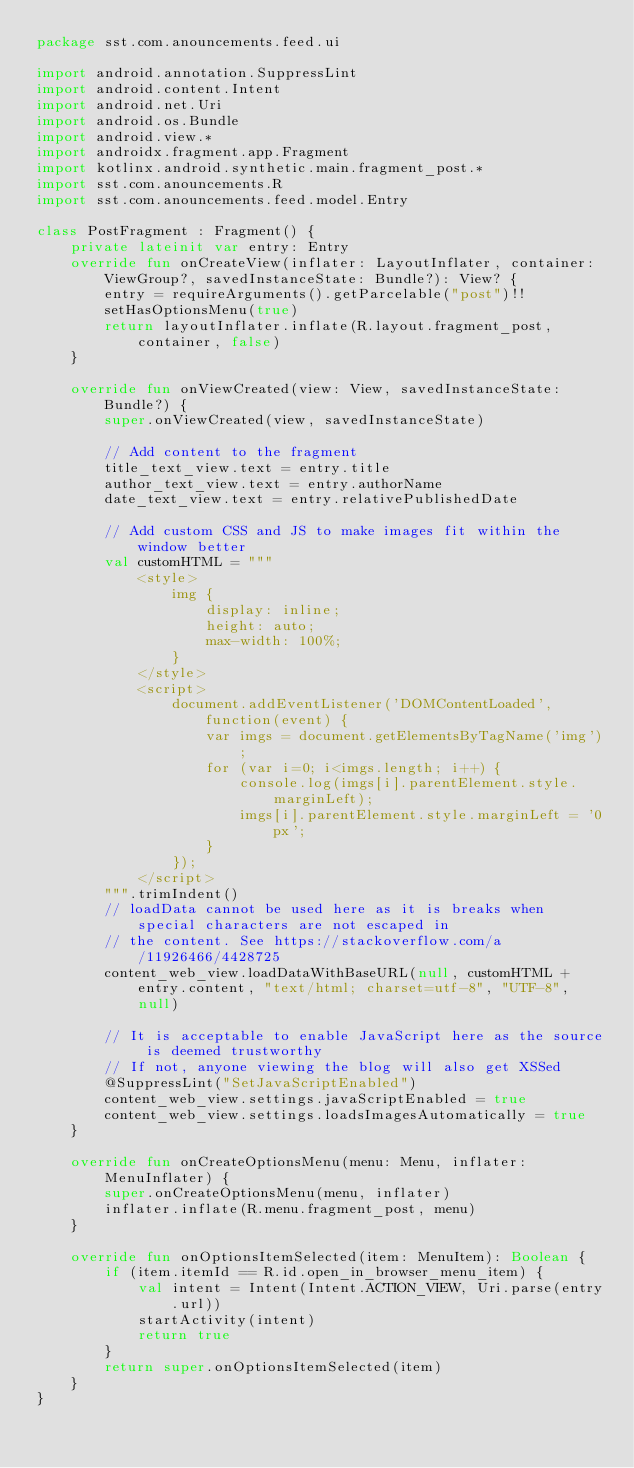<code> <loc_0><loc_0><loc_500><loc_500><_Kotlin_>package sst.com.anouncements.feed.ui

import android.annotation.SuppressLint
import android.content.Intent
import android.net.Uri
import android.os.Bundle
import android.view.*
import androidx.fragment.app.Fragment
import kotlinx.android.synthetic.main.fragment_post.*
import sst.com.anouncements.R
import sst.com.anouncements.feed.model.Entry

class PostFragment : Fragment() {
    private lateinit var entry: Entry
    override fun onCreateView(inflater: LayoutInflater, container: ViewGroup?, savedInstanceState: Bundle?): View? {
        entry = requireArguments().getParcelable("post")!!
        setHasOptionsMenu(true)
        return layoutInflater.inflate(R.layout.fragment_post, container, false)
    }

    override fun onViewCreated(view: View, savedInstanceState: Bundle?) {
        super.onViewCreated(view, savedInstanceState)

        // Add content to the fragment
        title_text_view.text = entry.title
        author_text_view.text = entry.authorName
        date_text_view.text = entry.relativePublishedDate

        // Add custom CSS and JS to make images fit within the window better
        val customHTML = """
            <style>
                img {
                    display: inline;
                    height: auto;
                    max-width: 100%;
                }
            </style>
            <script>
                document.addEventListener('DOMContentLoaded', function(event) {
                    var imgs = document.getElementsByTagName('img');
                    for (var i=0; i<imgs.length; i++) {
                        console.log(imgs[i].parentElement.style.marginLeft);
                        imgs[i].parentElement.style.marginLeft = '0px';
                    }
                });
            </script>
        """.trimIndent()
        // loadData cannot be used here as it is breaks when special characters are not escaped in
        // the content. See https://stackoverflow.com/a/11926466/4428725
        content_web_view.loadDataWithBaseURL(null, customHTML + entry.content, "text/html; charset=utf-8", "UTF-8", null)

        // It is acceptable to enable JavaScript here as the source is deemed trustworthy
        // If not, anyone viewing the blog will also get XSSed
        @SuppressLint("SetJavaScriptEnabled")
        content_web_view.settings.javaScriptEnabled = true
        content_web_view.settings.loadsImagesAutomatically = true
    }

    override fun onCreateOptionsMenu(menu: Menu, inflater: MenuInflater) {
        super.onCreateOptionsMenu(menu, inflater)
        inflater.inflate(R.menu.fragment_post, menu)
    }

    override fun onOptionsItemSelected(item: MenuItem): Boolean {
        if (item.itemId == R.id.open_in_browser_menu_item) {
            val intent = Intent(Intent.ACTION_VIEW, Uri.parse(entry.url))
            startActivity(intent)
            return true
        }
        return super.onOptionsItemSelected(item)
    }
}</code> 